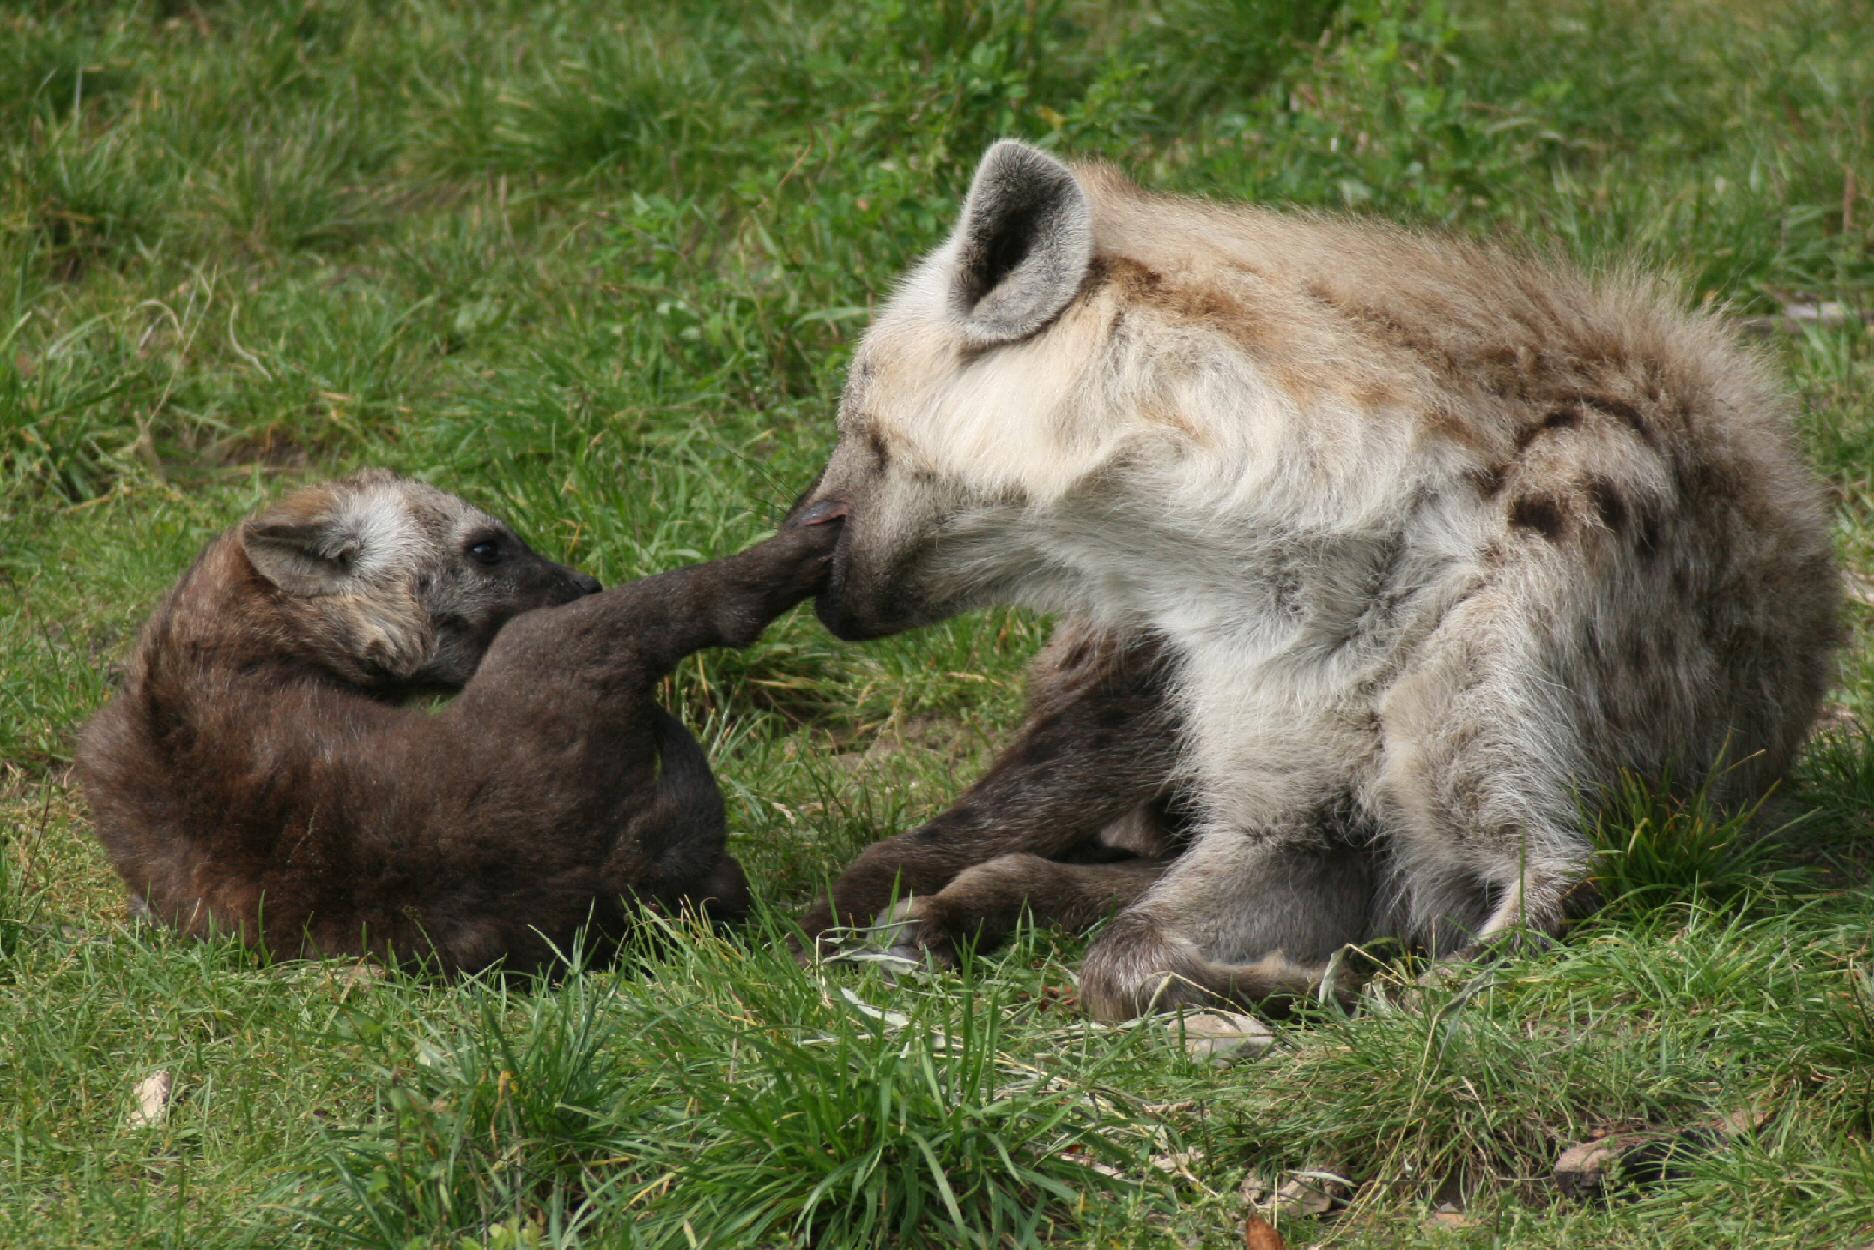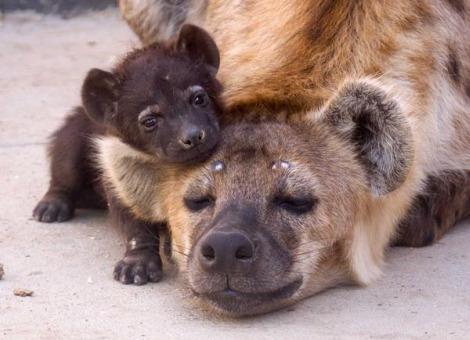The first image is the image on the left, the second image is the image on the right. Given the left and right images, does the statement "An image shows a dark baby hyena posed with its head over the ear of a reclining adult hyena." hold true? Answer yes or no. Yes. The first image is the image on the left, the second image is the image on the right. For the images shown, is this caption "The left image contains two hyenas." true? Answer yes or no. Yes. 